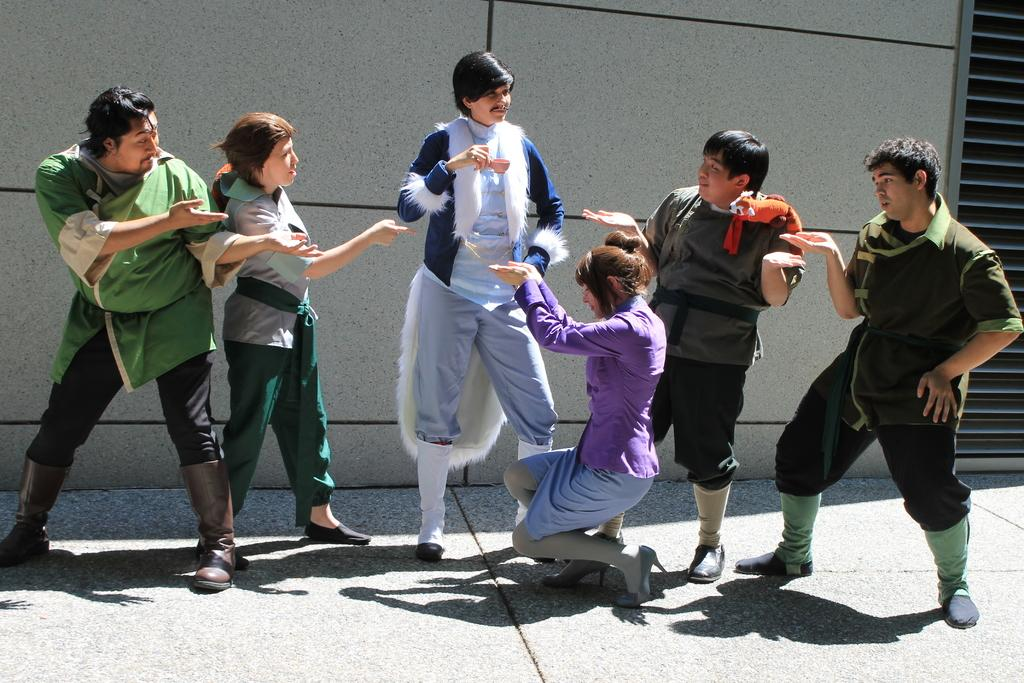Who or what is present in the image? There are people in the image. Can you describe the location of the people in the image? The people are in the center of the image. What type of nut is being cracked by the people in the image? There is no nut present in the image, nor are the people shown cracking any nuts. 